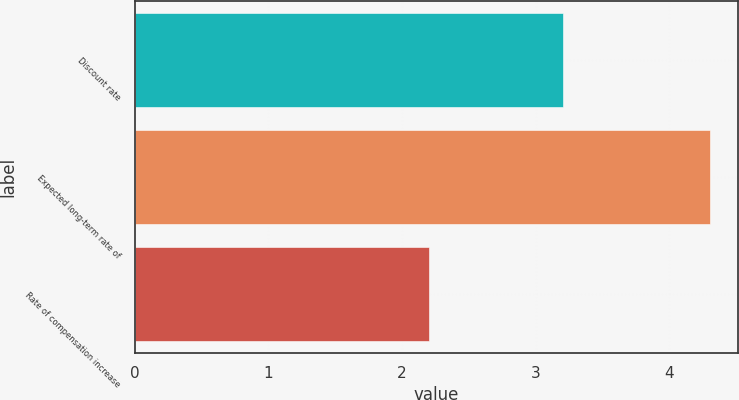Convert chart to OTSL. <chart><loc_0><loc_0><loc_500><loc_500><bar_chart><fcel>Discount rate<fcel>Expected long-term rate of<fcel>Rate of compensation increase<nl><fcel>3.2<fcel>4.3<fcel>2.2<nl></chart> 